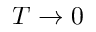Convert formula to latex. <formula><loc_0><loc_0><loc_500><loc_500>T \rightarrow 0</formula> 